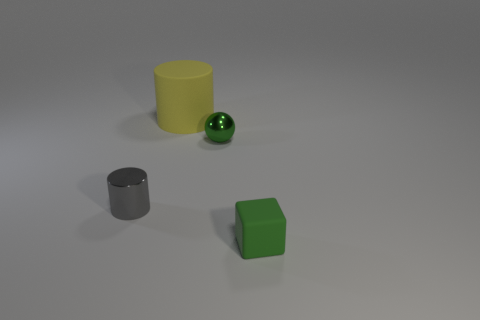Are there fewer green objects than small green matte cubes?
Offer a very short reply. No. Is there any other thing that has the same size as the yellow cylinder?
Provide a succinct answer. No. Do the block and the shiny ball have the same color?
Your response must be concise. Yes. Are there more yellow cylinders than small brown things?
Provide a succinct answer. Yes. How many other objects are there of the same color as the metallic cylinder?
Offer a very short reply. 0. How many tiny green metallic objects are right of the green object left of the cube?
Your response must be concise. 0. Are there any big cylinders behind the small cylinder?
Your response must be concise. Yes. The small metallic thing that is right of the cylinder right of the tiny gray cylinder is what shape?
Provide a short and direct response. Sphere. Are there fewer rubber cylinders on the left side of the large yellow rubber cylinder than green rubber cubes that are left of the sphere?
Give a very brief answer. No. What color is the tiny object that is the same shape as the big thing?
Make the answer very short. Gray. 